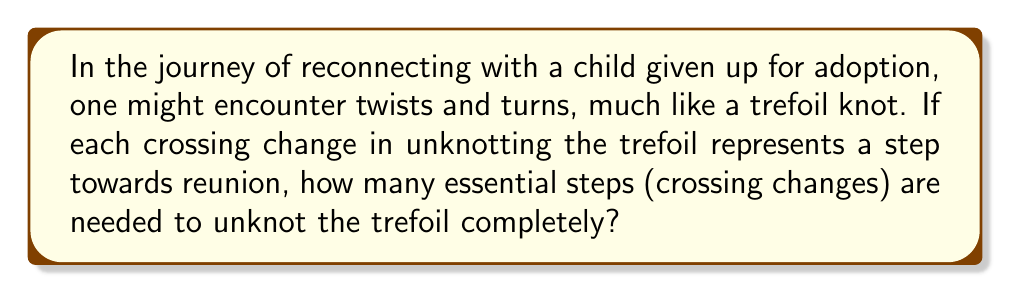What is the answer to this math problem? To determine the unknotting number of a trefoil knot, we follow these steps:

1) First, recall that the trefoil knot is the simplest non-trivial knot, represented by the knot diagram:

[asy]
import geometry;

pair A=(0,0), B=(1,0), C=(0.5,0.866);
draw(A--B--C--cycle);
draw(A{right}..{up}(0.33,0.33){up}..{left}C);
draw(B{left}..{up}(0.67,0.33){up}..{right}C);
draw(A{right}..{down}(0.67,-0.33){down}..{left}B);
</asy]

2) The unknotting number is the minimum number of crossing changes required to transform the knot into the unknot (trivial knot).

3) For the trefoil knot, we can observe that changing any one of the three crossings does not unknot it. This means the unknotting number must be greater than 1.

4) However, changing any two crossings will result in the unknot. For example:

[asy]
import geometry;

pair A=(0,0), B=(1,0), C=(0.5,0.866);
draw(A--B--C--cycle);
draw(A{right}..{up}(0.33,0.33){up}..{left}C);
draw(B{left}..{down}(0.67,0.33){down}..{right}C);
draw(A{right}..{up}(0.67,-0.33){up}..{left}B);
</asy]

5) This demonstrates that two crossing changes are sufficient to unknot the trefoil.

6) Since we've shown that one change is not enough and two changes are sufficient, we can conclude that the unknotting number of the trefoil knot is exactly 2.

This result is mathematically proven and well-established in knot theory.
Answer: 2 